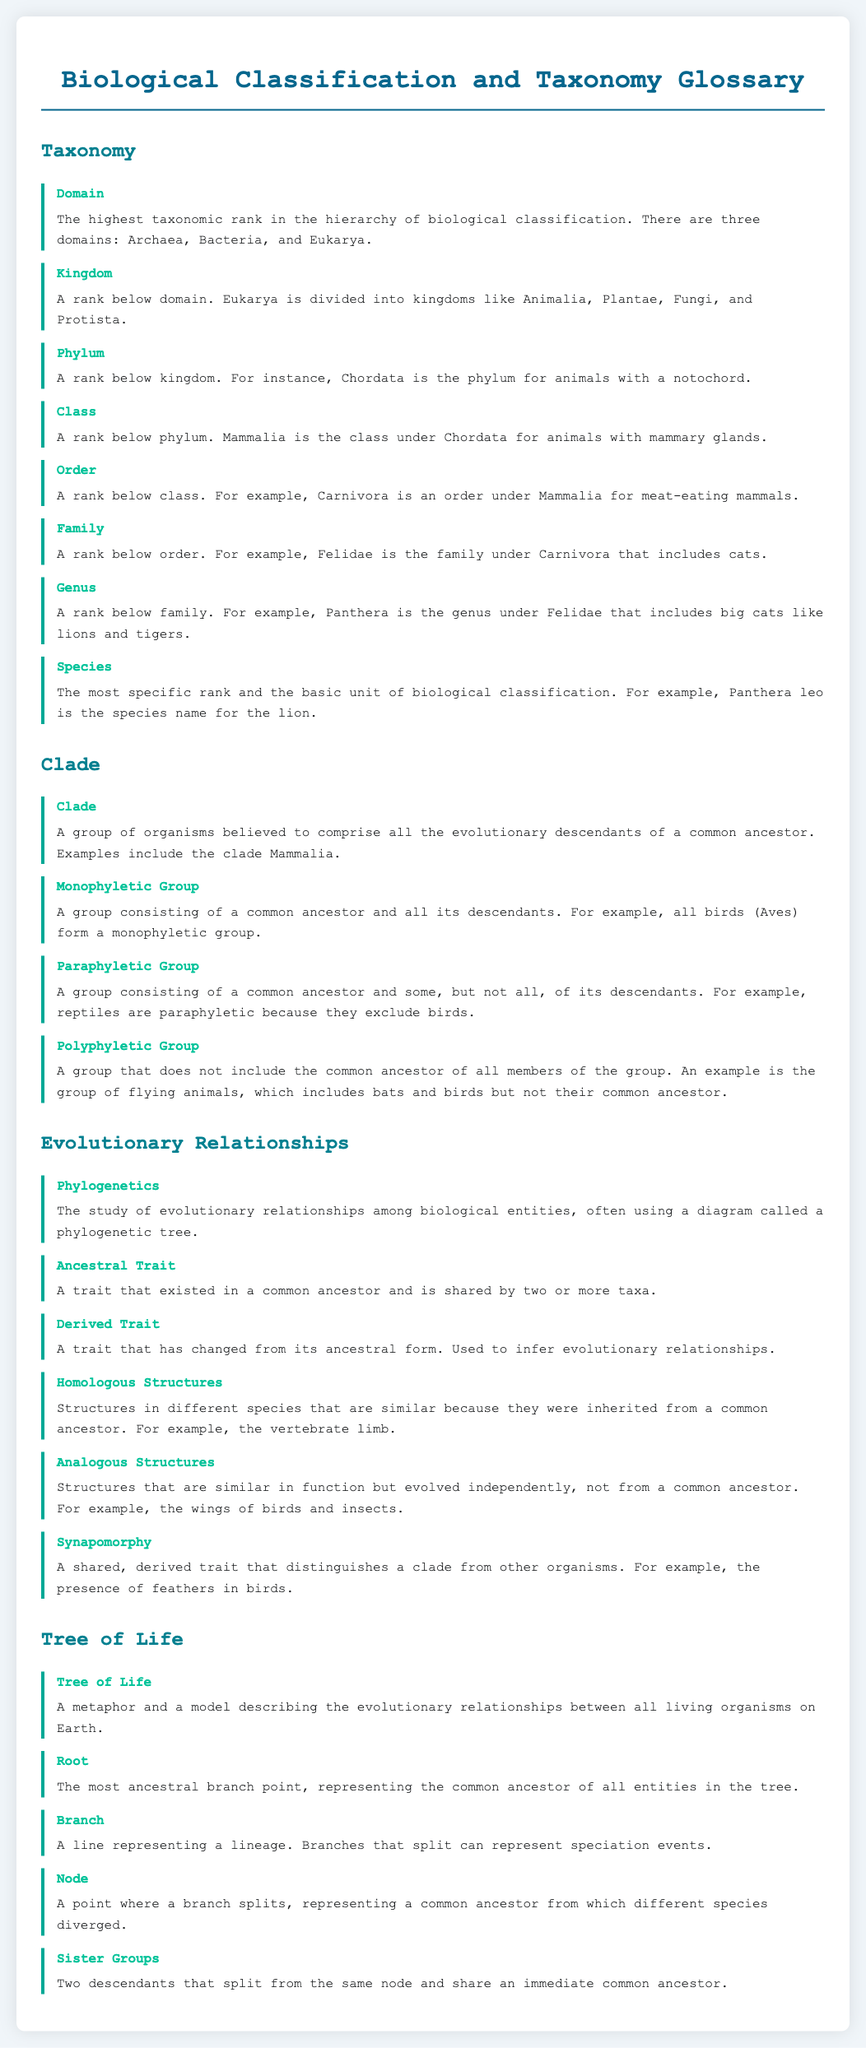What is the highest taxonomic rank in biological classification? The document states that the highest taxonomic rank is Domain.
Answer: Domain Which clade includes all birds? The term "Aves" refers to the clade that includes all birds, as mentioned in the document.
Answer: Aves What taxonomic rank is below the Kingdom? According to the definitions provided, the rank below Kingdom is Phylum.
Answer: Phylum What type of group excludes some descendants of a common ancestor? The document defines a Paraphyletic Group as one that excludes some descendants of a common ancestor.
Answer: Paraphyletic Group What trait is shared by two or more taxa that existed in a common ancestor? The term used in the document for a shared trait that existed in a common ancestor is Ancestral Trait.
Answer: Ancestral Trait What is represented at the Root of the Tree of Life? The document states that the Root represents the common ancestor of all entities in the tree.
Answer: Common ancestor What kind of structures are similar because they were inherited from a common ancestor? The document explains Homologous Structures as those that are similar due to inheritance from a common ancestor.
Answer: Homologous Structures What does the term Synapomorphy refer to? Synapomorphy is defined as a shared, derived trait that distinguishes a clade from other organisms.
Answer: Shared, derived trait What is the study of evolutionary relationships called? The document indicates that the study of evolutionary relationships among biological entities is called Phylogenetics.
Answer: Phylogenetics 